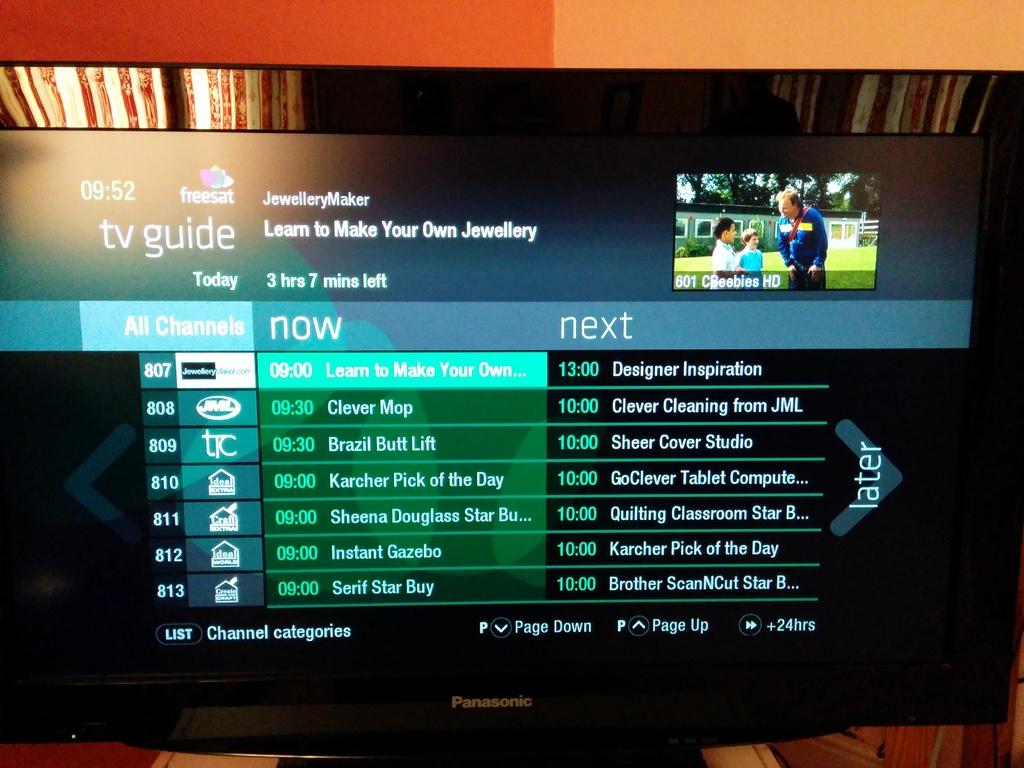What is currently being played on channel 812?
Ensure brevity in your answer.  Instant gazebo. What time is clever mop on?
Make the answer very short. 9:30. 